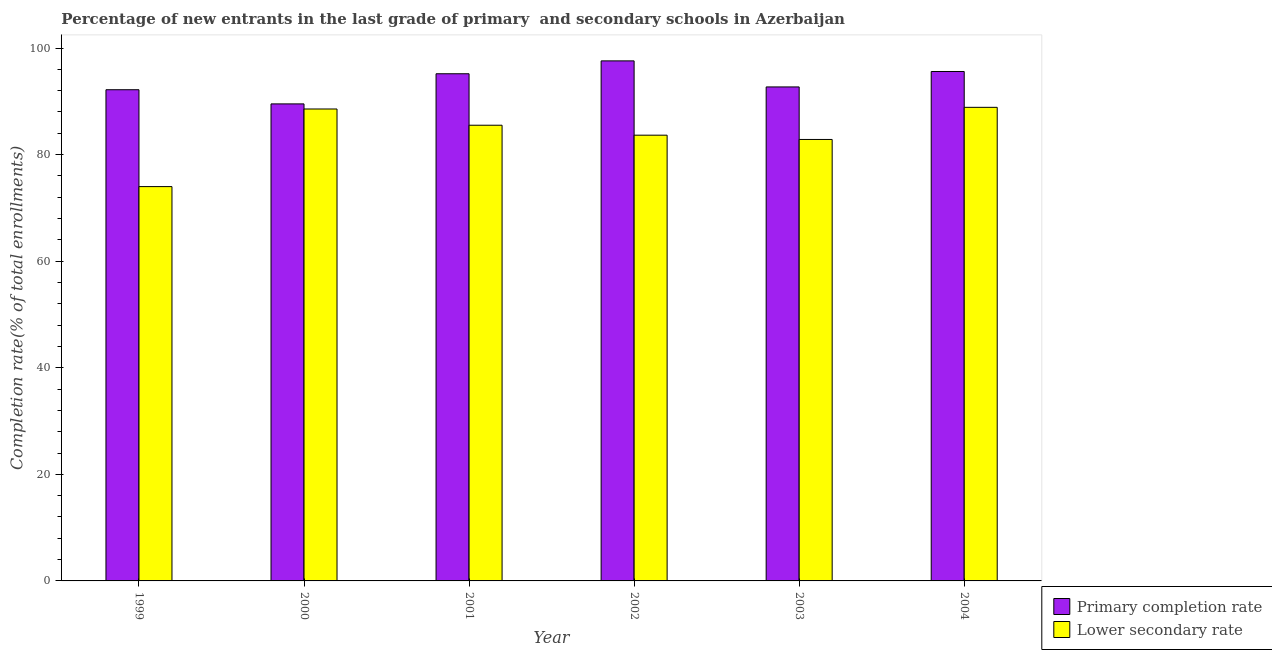How many different coloured bars are there?
Offer a very short reply. 2. How many groups of bars are there?
Your answer should be very brief. 6. Are the number of bars on each tick of the X-axis equal?
Provide a succinct answer. Yes. What is the completion rate in secondary schools in 2003?
Your answer should be compact. 82.84. Across all years, what is the maximum completion rate in secondary schools?
Provide a short and direct response. 88.87. Across all years, what is the minimum completion rate in secondary schools?
Make the answer very short. 74. In which year was the completion rate in primary schools maximum?
Make the answer very short. 2002. What is the total completion rate in secondary schools in the graph?
Make the answer very short. 503.41. What is the difference between the completion rate in secondary schools in 2000 and that in 2004?
Provide a succinct answer. -0.31. What is the difference between the completion rate in secondary schools in 1999 and the completion rate in primary schools in 2000?
Your response must be concise. -14.56. What is the average completion rate in primary schools per year?
Provide a short and direct response. 93.79. In the year 2000, what is the difference between the completion rate in secondary schools and completion rate in primary schools?
Provide a short and direct response. 0. In how many years, is the completion rate in secondary schools greater than 80 %?
Keep it short and to the point. 5. What is the ratio of the completion rate in secondary schools in 2003 to that in 2004?
Your response must be concise. 0.93. What is the difference between the highest and the second highest completion rate in primary schools?
Offer a very short reply. 1.99. What is the difference between the highest and the lowest completion rate in secondary schools?
Offer a very short reply. 14.87. What does the 1st bar from the left in 2003 represents?
Ensure brevity in your answer.  Primary completion rate. What does the 1st bar from the right in 1999 represents?
Provide a short and direct response. Lower secondary rate. Does the graph contain any zero values?
Give a very brief answer. No. How many legend labels are there?
Offer a terse response. 2. What is the title of the graph?
Provide a short and direct response. Percentage of new entrants in the last grade of primary  and secondary schools in Azerbaijan. Does "International Tourists" appear as one of the legend labels in the graph?
Offer a terse response. No. What is the label or title of the Y-axis?
Your answer should be compact. Completion rate(% of total enrollments). What is the Completion rate(% of total enrollments) of Primary completion rate in 1999?
Your answer should be very brief. 92.17. What is the Completion rate(% of total enrollments) in Lower secondary rate in 1999?
Provide a short and direct response. 74. What is the Completion rate(% of total enrollments) of Primary completion rate in 2000?
Provide a short and direct response. 89.51. What is the Completion rate(% of total enrollments) in Lower secondary rate in 2000?
Your response must be concise. 88.56. What is the Completion rate(% of total enrollments) of Primary completion rate in 2001?
Your answer should be compact. 95.17. What is the Completion rate(% of total enrollments) in Lower secondary rate in 2001?
Ensure brevity in your answer.  85.51. What is the Completion rate(% of total enrollments) of Primary completion rate in 2002?
Provide a short and direct response. 97.59. What is the Completion rate(% of total enrollments) in Lower secondary rate in 2002?
Your answer should be compact. 83.64. What is the Completion rate(% of total enrollments) of Primary completion rate in 2003?
Provide a succinct answer. 92.7. What is the Completion rate(% of total enrollments) of Lower secondary rate in 2003?
Your response must be concise. 82.84. What is the Completion rate(% of total enrollments) of Primary completion rate in 2004?
Give a very brief answer. 95.6. What is the Completion rate(% of total enrollments) of Lower secondary rate in 2004?
Make the answer very short. 88.87. Across all years, what is the maximum Completion rate(% of total enrollments) in Primary completion rate?
Your response must be concise. 97.59. Across all years, what is the maximum Completion rate(% of total enrollments) in Lower secondary rate?
Ensure brevity in your answer.  88.87. Across all years, what is the minimum Completion rate(% of total enrollments) in Primary completion rate?
Your answer should be compact. 89.51. Across all years, what is the minimum Completion rate(% of total enrollments) of Lower secondary rate?
Offer a very short reply. 74. What is the total Completion rate(% of total enrollments) in Primary completion rate in the graph?
Make the answer very short. 562.73. What is the total Completion rate(% of total enrollments) of Lower secondary rate in the graph?
Offer a terse response. 503.41. What is the difference between the Completion rate(% of total enrollments) of Primary completion rate in 1999 and that in 2000?
Offer a terse response. 2.66. What is the difference between the Completion rate(% of total enrollments) of Lower secondary rate in 1999 and that in 2000?
Give a very brief answer. -14.56. What is the difference between the Completion rate(% of total enrollments) of Primary completion rate in 1999 and that in 2001?
Keep it short and to the point. -3. What is the difference between the Completion rate(% of total enrollments) of Lower secondary rate in 1999 and that in 2001?
Your response must be concise. -11.51. What is the difference between the Completion rate(% of total enrollments) of Primary completion rate in 1999 and that in 2002?
Your answer should be very brief. -5.41. What is the difference between the Completion rate(% of total enrollments) of Lower secondary rate in 1999 and that in 2002?
Offer a very short reply. -9.65. What is the difference between the Completion rate(% of total enrollments) in Primary completion rate in 1999 and that in 2003?
Offer a very short reply. -0.52. What is the difference between the Completion rate(% of total enrollments) in Lower secondary rate in 1999 and that in 2003?
Give a very brief answer. -8.85. What is the difference between the Completion rate(% of total enrollments) in Primary completion rate in 1999 and that in 2004?
Make the answer very short. -3.42. What is the difference between the Completion rate(% of total enrollments) of Lower secondary rate in 1999 and that in 2004?
Keep it short and to the point. -14.87. What is the difference between the Completion rate(% of total enrollments) in Primary completion rate in 2000 and that in 2001?
Your response must be concise. -5.66. What is the difference between the Completion rate(% of total enrollments) of Lower secondary rate in 2000 and that in 2001?
Your answer should be compact. 3.05. What is the difference between the Completion rate(% of total enrollments) in Primary completion rate in 2000 and that in 2002?
Offer a very short reply. -8.07. What is the difference between the Completion rate(% of total enrollments) in Lower secondary rate in 2000 and that in 2002?
Make the answer very short. 4.91. What is the difference between the Completion rate(% of total enrollments) in Primary completion rate in 2000 and that in 2003?
Provide a succinct answer. -3.18. What is the difference between the Completion rate(% of total enrollments) of Lower secondary rate in 2000 and that in 2003?
Your response must be concise. 5.72. What is the difference between the Completion rate(% of total enrollments) in Primary completion rate in 2000 and that in 2004?
Make the answer very short. -6.08. What is the difference between the Completion rate(% of total enrollments) of Lower secondary rate in 2000 and that in 2004?
Keep it short and to the point. -0.31. What is the difference between the Completion rate(% of total enrollments) in Primary completion rate in 2001 and that in 2002?
Ensure brevity in your answer.  -2.42. What is the difference between the Completion rate(% of total enrollments) in Lower secondary rate in 2001 and that in 2002?
Your answer should be compact. 1.87. What is the difference between the Completion rate(% of total enrollments) in Primary completion rate in 2001 and that in 2003?
Your response must be concise. 2.47. What is the difference between the Completion rate(% of total enrollments) in Lower secondary rate in 2001 and that in 2003?
Make the answer very short. 2.67. What is the difference between the Completion rate(% of total enrollments) in Primary completion rate in 2001 and that in 2004?
Your answer should be compact. -0.43. What is the difference between the Completion rate(% of total enrollments) in Lower secondary rate in 2001 and that in 2004?
Ensure brevity in your answer.  -3.36. What is the difference between the Completion rate(% of total enrollments) in Primary completion rate in 2002 and that in 2003?
Provide a short and direct response. 4.89. What is the difference between the Completion rate(% of total enrollments) in Lower secondary rate in 2002 and that in 2003?
Make the answer very short. 0.8. What is the difference between the Completion rate(% of total enrollments) in Primary completion rate in 2002 and that in 2004?
Provide a short and direct response. 1.99. What is the difference between the Completion rate(% of total enrollments) in Lower secondary rate in 2002 and that in 2004?
Give a very brief answer. -5.23. What is the difference between the Completion rate(% of total enrollments) of Primary completion rate in 2003 and that in 2004?
Offer a terse response. -2.9. What is the difference between the Completion rate(% of total enrollments) of Lower secondary rate in 2003 and that in 2004?
Keep it short and to the point. -6.03. What is the difference between the Completion rate(% of total enrollments) of Primary completion rate in 1999 and the Completion rate(% of total enrollments) of Lower secondary rate in 2000?
Provide a succinct answer. 3.62. What is the difference between the Completion rate(% of total enrollments) in Primary completion rate in 1999 and the Completion rate(% of total enrollments) in Lower secondary rate in 2001?
Keep it short and to the point. 6.66. What is the difference between the Completion rate(% of total enrollments) in Primary completion rate in 1999 and the Completion rate(% of total enrollments) in Lower secondary rate in 2002?
Keep it short and to the point. 8.53. What is the difference between the Completion rate(% of total enrollments) in Primary completion rate in 1999 and the Completion rate(% of total enrollments) in Lower secondary rate in 2003?
Your response must be concise. 9.33. What is the difference between the Completion rate(% of total enrollments) in Primary completion rate in 1999 and the Completion rate(% of total enrollments) in Lower secondary rate in 2004?
Make the answer very short. 3.3. What is the difference between the Completion rate(% of total enrollments) in Primary completion rate in 2000 and the Completion rate(% of total enrollments) in Lower secondary rate in 2001?
Provide a succinct answer. 4. What is the difference between the Completion rate(% of total enrollments) in Primary completion rate in 2000 and the Completion rate(% of total enrollments) in Lower secondary rate in 2002?
Offer a very short reply. 5.87. What is the difference between the Completion rate(% of total enrollments) in Primary completion rate in 2000 and the Completion rate(% of total enrollments) in Lower secondary rate in 2003?
Offer a terse response. 6.67. What is the difference between the Completion rate(% of total enrollments) in Primary completion rate in 2000 and the Completion rate(% of total enrollments) in Lower secondary rate in 2004?
Ensure brevity in your answer.  0.64. What is the difference between the Completion rate(% of total enrollments) of Primary completion rate in 2001 and the Completion rate(% of total enrollments) of Lower secondary rate in 2002?
Make the answer very short. 11.53. What is the difference between the Completion rate(% of total enrollments) of Primary completion rate in 2001 and the Completion rate(% of total enrollments) of Lower secondary rate in 2003?
Provide a succinct answer. 12.33. What is the difference between the Completion rate(% of total enrollments) of Primary completion rate in 2001 and the Completion rate(% of total enrollments) of Lower secondary rate in 2004?
Give a very brief answer. 6.3. What is the difference between the Completion rate(% of total enrollments) of Primary completion rate in 2002 and the Completion rate(% of total enrollments) of Lower secondary rate in 2003?
Offer a terse response. 14.75. What is the difference between the Completion rate(% of total enrollments) in Primary completion rate in 2002 and the Completion rate(% of total enrollments) in Lower secondary rate in 2004?
Ensure brevity in your answer.  8.72. What is the difference between the Completion rate(% of total enrollments) of Primary completion rate in 2003 and the Completion rate(% of total enrollments) of Lower secondary rate in 2004?
Ensure brevity in your answer.  3.83. What is the average Completion rate(% of total enrollments) in Primary completion rate per year?
Keep it short and to the point. 93.79. What is the average Completion rate(% of total enrollments) in Lower secondary rate per year?
Ensure brevity in your answer.  83.9. In the year 1999, what is the difference between the Completion rate(% of total enrollments) of Primary completion rate and Completion rate(% of total enrollments) of Lower secondary rate?
Provide a succinct answer. 18.18. In the year 2000, what is the difference between the Completion rate(% of total enrollments) in Primary completion rate and Completion rate(% of total enrollments) in Lower secondary rate?
Make the answer very short. 0.96. In the year 2001, what is the difference between the Completion rate(% of total enrollments) of Primary completion rate and Completion rate(% of total enrollments) of Lower secondary rate?
Provide a succinct answer. 9.66. In the year 2002, what is the difference between the Completion rate(% of total enrollments) in Primary completion rate and Completion rate(% of total enrollments) in Lower secondary rate?
Give a very brief answer. 13.94. In the year 2003, what is the difference between the Completion rate(% of total enrollments) of Primary completion rate and Completion rate(% of total enrollments) of Lower secondary rate?
Your response must be concise. 9.86. In the year 2004, what is the difference between the Completion rate(% of total enrollments) of Primary completion rate and Completion rate(% of total enrollments) of Lower secondary rate?
Your answer should be very brief. 6.73. What is the ratio of the Completion rate(% of total enrollments) in Primary completion rate in 1999 to that in 2000?
Ensure brevity in your answer.  1.03. What is the ratio of the Completion rate(% of total enrollments) in Lower secondary rate in 1999 to that in 2000?
Give a very brief answer. 0.84. What is the ratio of the Completion rate(% of total enrollments) in Primary completion rate in 1999 to that in 2001?
Your answer should be compact. 0.97. What is the ratio of the Completion rate(% of total enrollments) in Lower secondary rate in 1999 to that in 2001?
Ensure brevity in your answer.  0.87. What is the ratio of the Completion rate(% of total enrollments) of Primary completion rate in 1999 to that in 2002?
Ensure brevity in your answer.  0.94. What is the ratio of the Completion rate(% of total enrollments) in Lower secondary rate in 1999 to that in 2002?
Your answer should be compact. 0.88. What is the ratio of the Completion rate(% of total enrollments) in Lower secondary rate in 1999 to that in 2003?
Offer a terse response. 0.89. What is the ratio of the Completion rate(% of total enrollments) of Primary completion rate in 1999 to that in 2004?
Offer a very short reply. 0.96. What is the ratio of the Completion rate(% of total enrollments) in Lower secondary rate in 1999 to that in 2004?
Offer a terse response. 0.83. What is the ratio of the Completion rate(% of total enrollments) of Primary completion rate in 2000 to that in 2001?
Offer a terse response. 0.94. What is the ratio of the Completion rate(% of total enrollments) of Lower secondary rate in 2000 to that in 2001?
Your response must be concise. 1.04. What is the ratio of the Completion rate(% of total enrollments) of Primary completion rate in 2000 to that in 2002?
Ensure brevity in your answer.  0.92. What is the ratio of the Completion rate(% of total enrollments) in Lower secondary rate in 2000 to that in 2002?
Offer a very short reply. 1.06. What is the ratio of the Completion rate(% of total enrollments) of Primary completion rate in 2000 to that in 2003?
Your response must be concise. 0.97. What is the ratio of the Completion rate(% of total enrollments) of Lower secondary rate in 2000 to that in 2003?
Give a very brief answer. 1.07. What is the ratio of the Completion rate(% of total enrollments) in Primary completion rate in 2000 to that in 2004?
Offer a very short reply. 0.94. What is the ratio of the Completion rate(% of total enrollments) in Primary completion rate in 2001 to that in 2002?
Offer a terse response. 0.98. What is the ratio of the Completion rate(% of total enrollments) in Lower secondary rate in 2001 to that in 2002?
Provide a succinct answer. 1.02. What is the ratio of the Completion rate(% of total enrollments) in Primary completion rate in 2001 to that in 2003?
Ensure brevity in your answer.  1.03. What is the ratio of the Completion rate(% of total enrollments) of Lower secondary rate in 2001 to that in 2003?
Provide a short and direct response. 1.03. What is the ratio of the Completion rate(% of total enrollments) of Primary completion rate in 2001 to that in 2004?
Ensure brevity in your answer.  1. What is the ratio of the Completion rate(% of total enrollments) in Lower secondary rate in 2001 to that in 2004?
Provide a succinct answer. 0.96. What is the ratio of the Completion rate(% of total enrollments) in Primary completion rate in 2002 to that in 2003?
Your answer should be compact. 1.05. What is the ratio of the Completion rate(% of total enrollments) in Lower secondary rate in 2002 to that in 2003?
Your answer should be compact. 1.01. What is the ratio of the Completion rate(% of total enrollments) of Primary completion rate in 2002 to that in 2004?
Give a very brief answer. 1.02. What is the ratio of the Completion rate(% of total enrollments) in Primary completion rate in 2003 to that in 2004?
Offer a very short reply. 0.97. What is the ratio of the Completion rate(% of total enrollments) of Lower secondary rate in 2003 to that in 2004?
Offer a terse response. 0.93. What is the difference between the highest and the second highest Completion rate(% of total enrollments) of Primary completion rate?
Offer a very short reply. 1.99. What is the difference between the highest and the second highest Completion rate(% of total enrollments) of Lower secondary rate?
Make the answer very short. 0.31. What is the difference between the highest and the lowest Completion rate(% of total enrollments) of Primary completion rate?
Your answer should be compact. 8.07. What is the difference between the highest and the lowest Completion rate(% of total enrollments) of Lower secondary rate?
Make the answer very short. 14.87. 